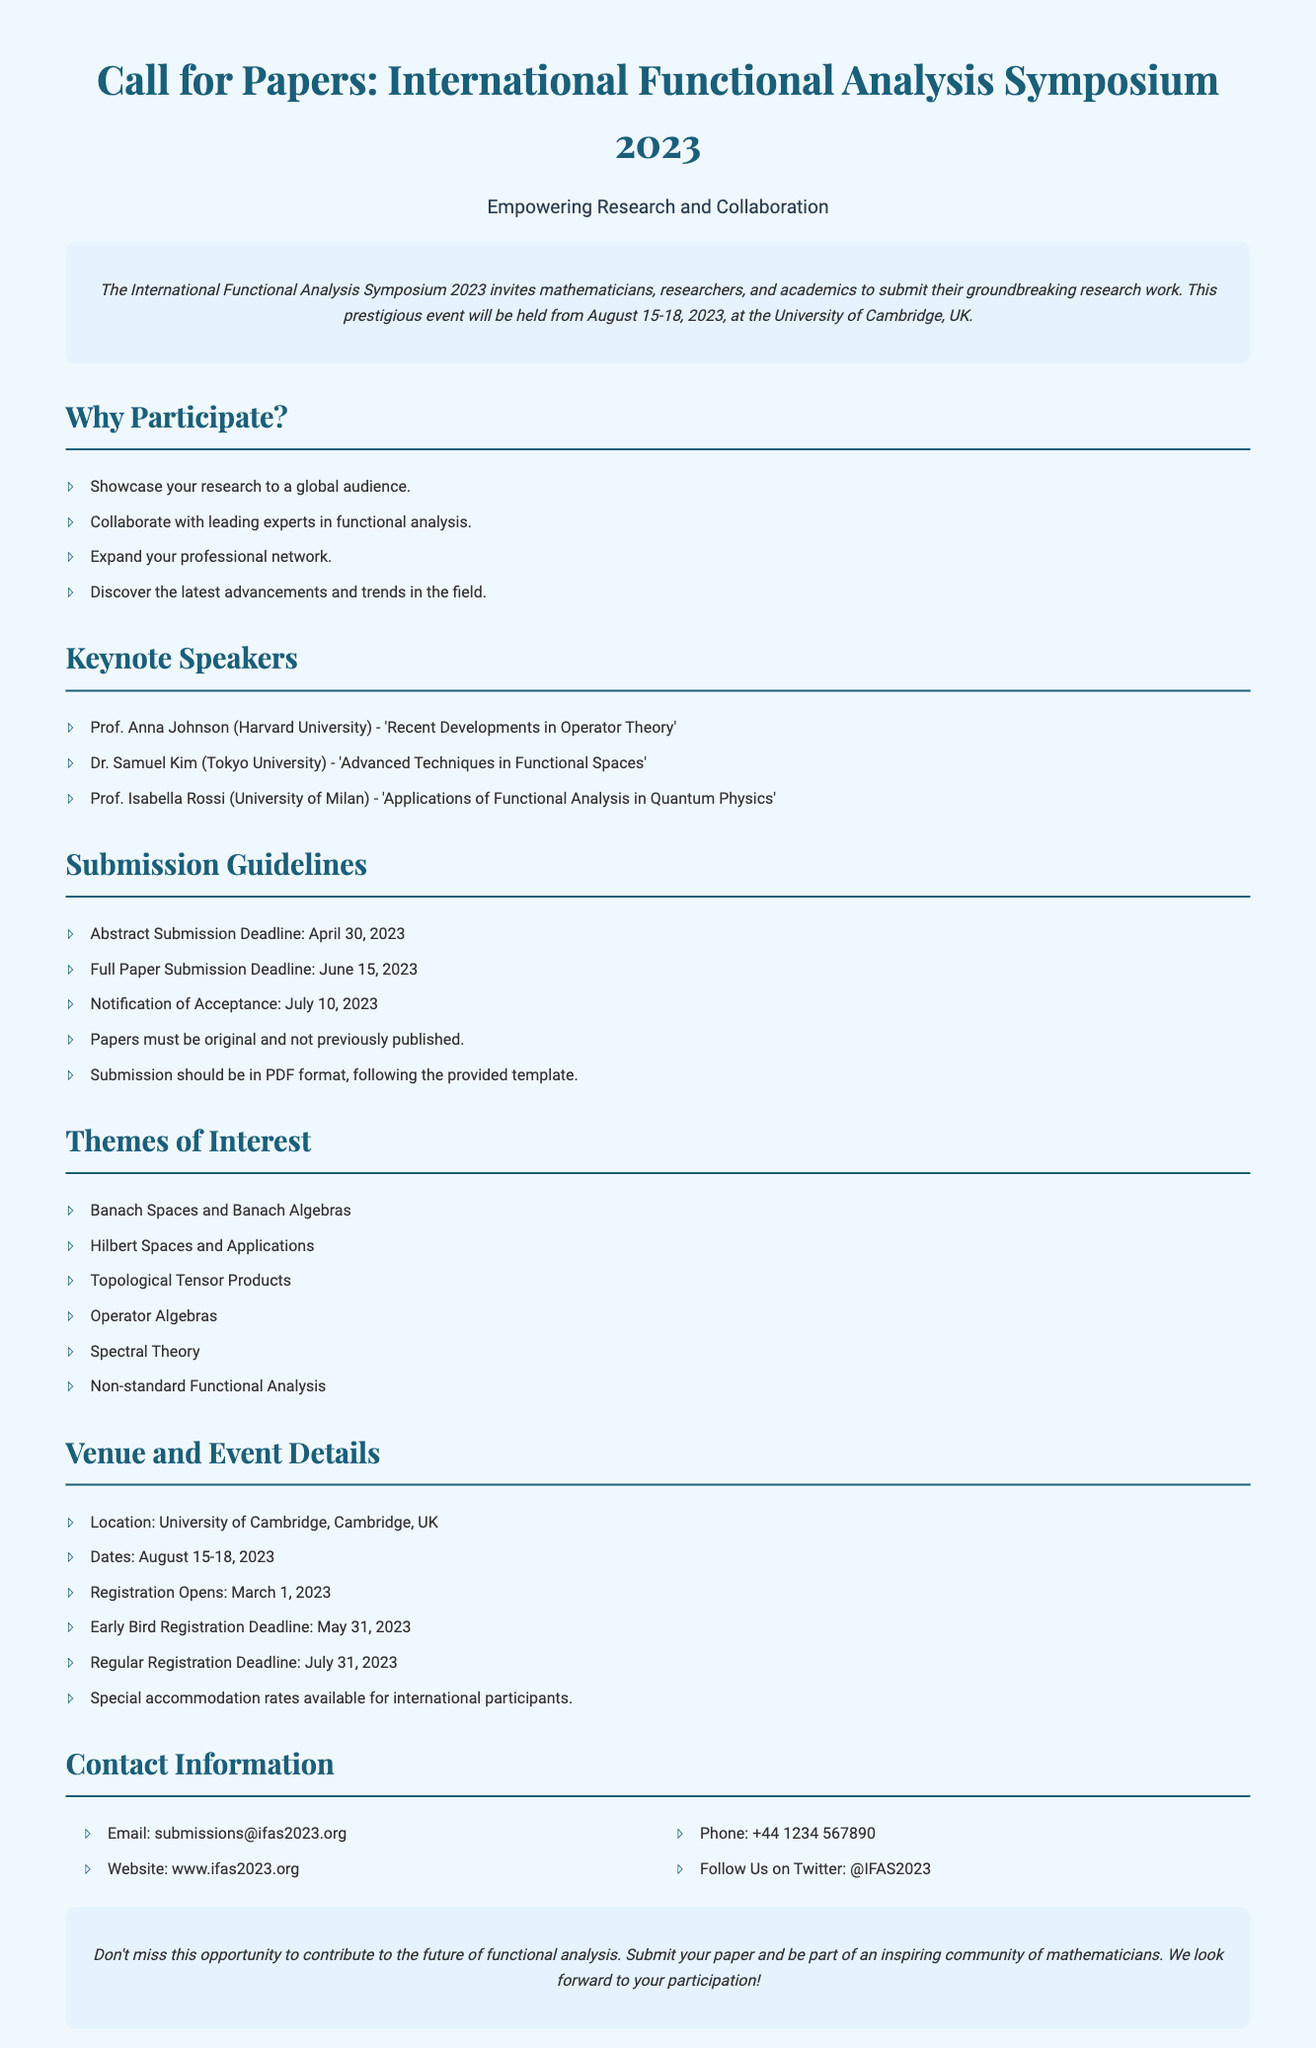What are the dates of the symposium? The dates of the symposium are mentioned in the overview section of the document.
Answer: August 15-18, 2023 Who is the keynote speaker from Harvard University? The document lists the keynote speakers, including their affiliations and topics.
Answer: Prof. Anna Johnson What is the abstract submission deadline? The deadlines for submissions are provided under the submission guidelines section.
Answer: April 30, 2023 Which theme of interest pertains to Banach Spaces? The themes of interest section specifically names several topics related to functional analysis.
Answer: Banach Spaces and Banach Algebras What is the early bird registration deadline? The registration deadlines are listed in the venue and event details section.
Answer: May 31, 2023 Where is the symposium being held? The venue and event details provide the location of the symposium.
Answer: University of Cambridge, UK How many keynote speakers are mentioned? The document lists the keynote speakers, indicating the total number.
Answer: Three What should submissions be formatted as? Submission guidelines state the required format for submitted papers.
Answer: PDF format Who to contact for submissions? The contact information section specifies the email for submissions.
Answer: submissions@ifas2023.org 